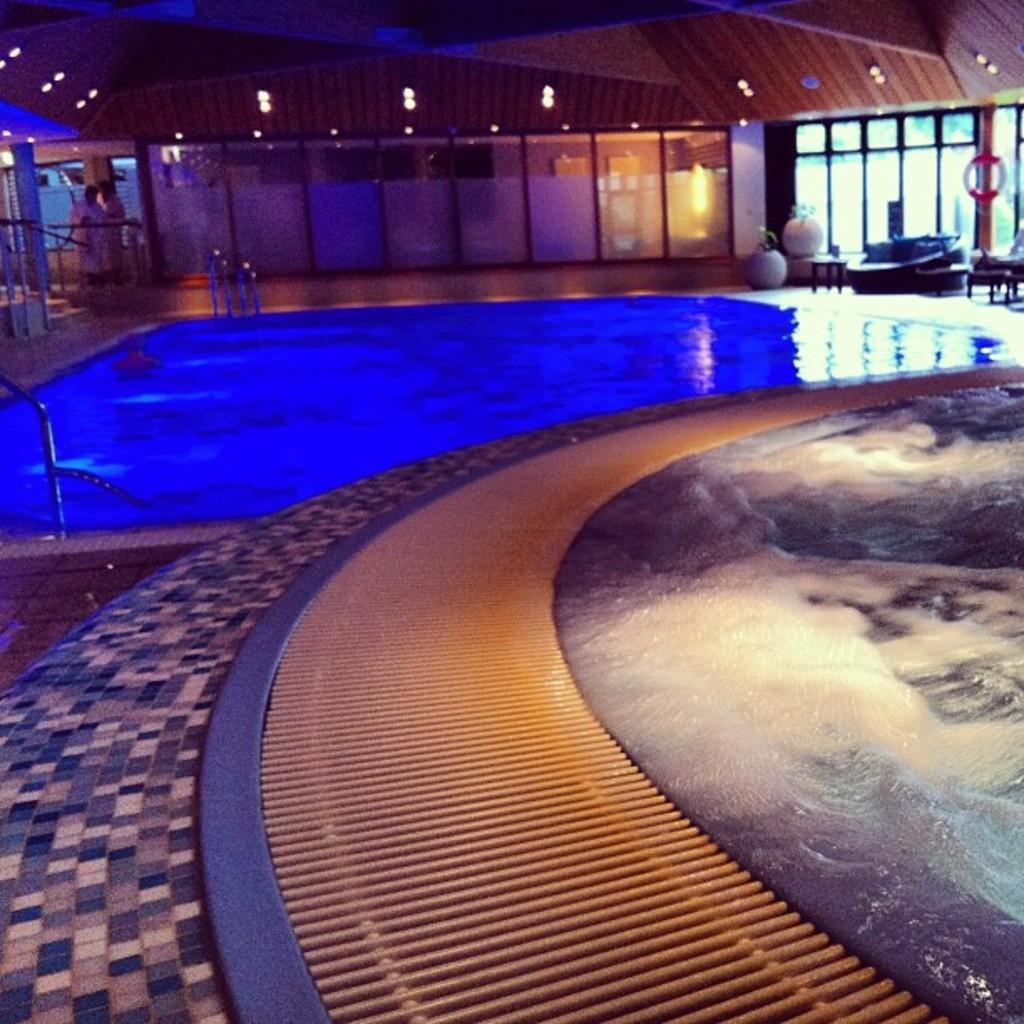Can you describe this image briefly? In the background we can see lights, floor, plants with pots. At the left side corner we can see two people standing. This is a swimming pool. 